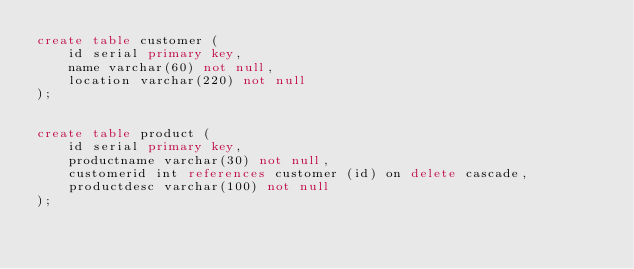<code> <loc_0><loc_0><loc_500><loc_500><_SQL_>create table customer (
	id serial primary key,
	name varchar(60) not null,
	location varchar(220) not null
);


create table product (
	id serial primary key,
	productname varchar(30) not null,
	customerid int references customer (id) on delete cascade,
	productdesc varchar(100) not null
);

</code> 